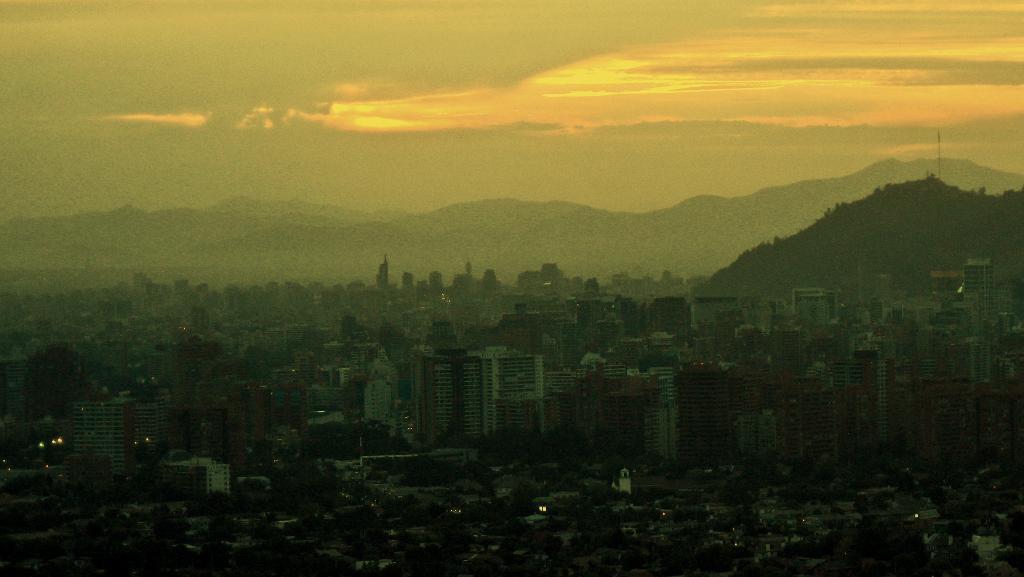Can you describe this image briefly? In this image we can see some buildings, trees and mountains, in the background, we can see the sky with clouds. 